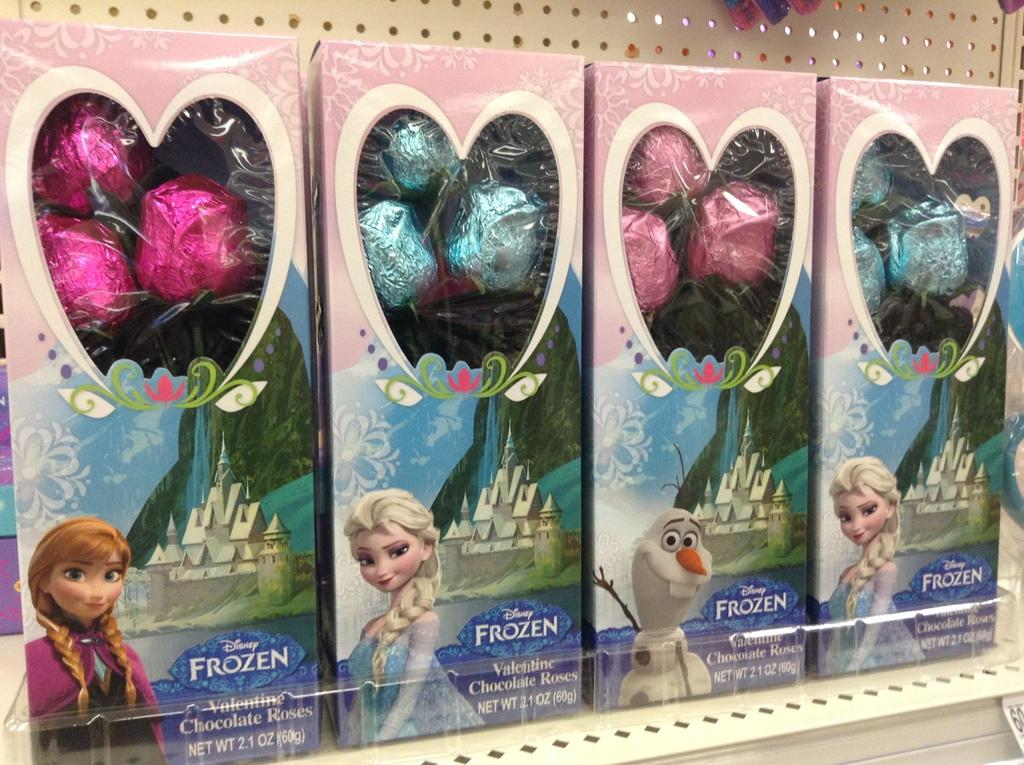What type of item is present in the image? There are chocolate boxes in the image. How are the chocolate boxes arranged? The chocolate boxes are kept in a rack. What is the color of the rack? The rack is white in color. How many chocolate boxes are visible in the image? There are four chocolate boxes. What type of heart can be seen beating inside one of the chocolate boxes? There is no heart visible inside any of the chocolate boxes in the image. 